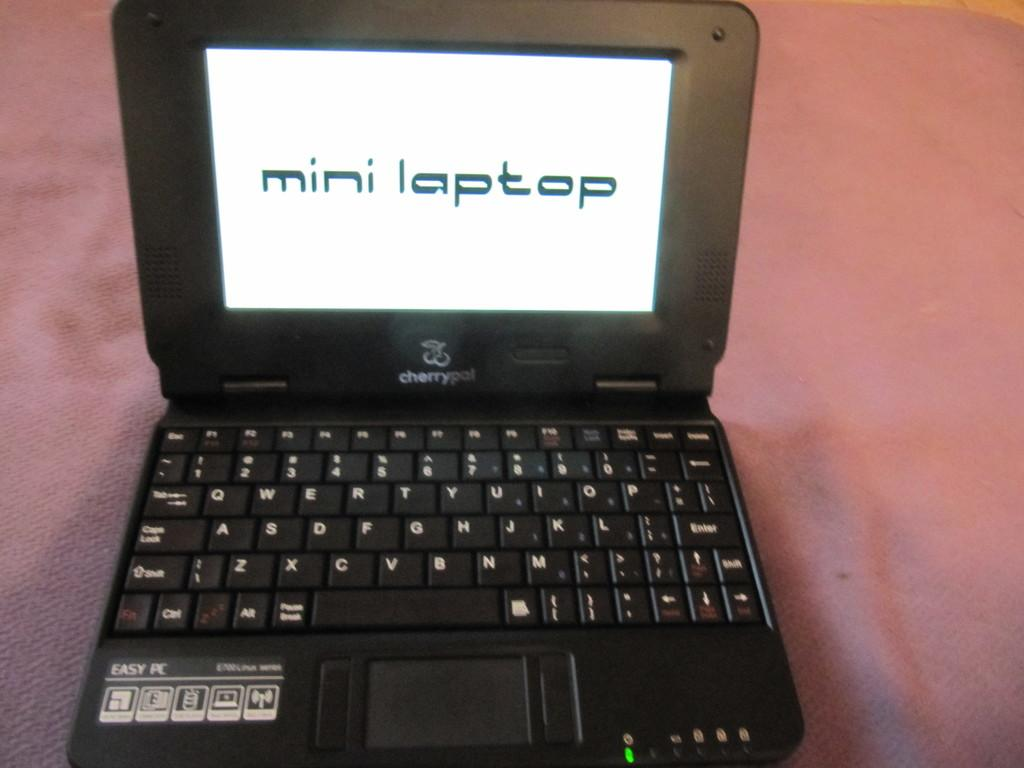<image>
Create a compact narrative representing the image presented. a black cherrypal laptop that has a screen on that says 'mini laptop' 